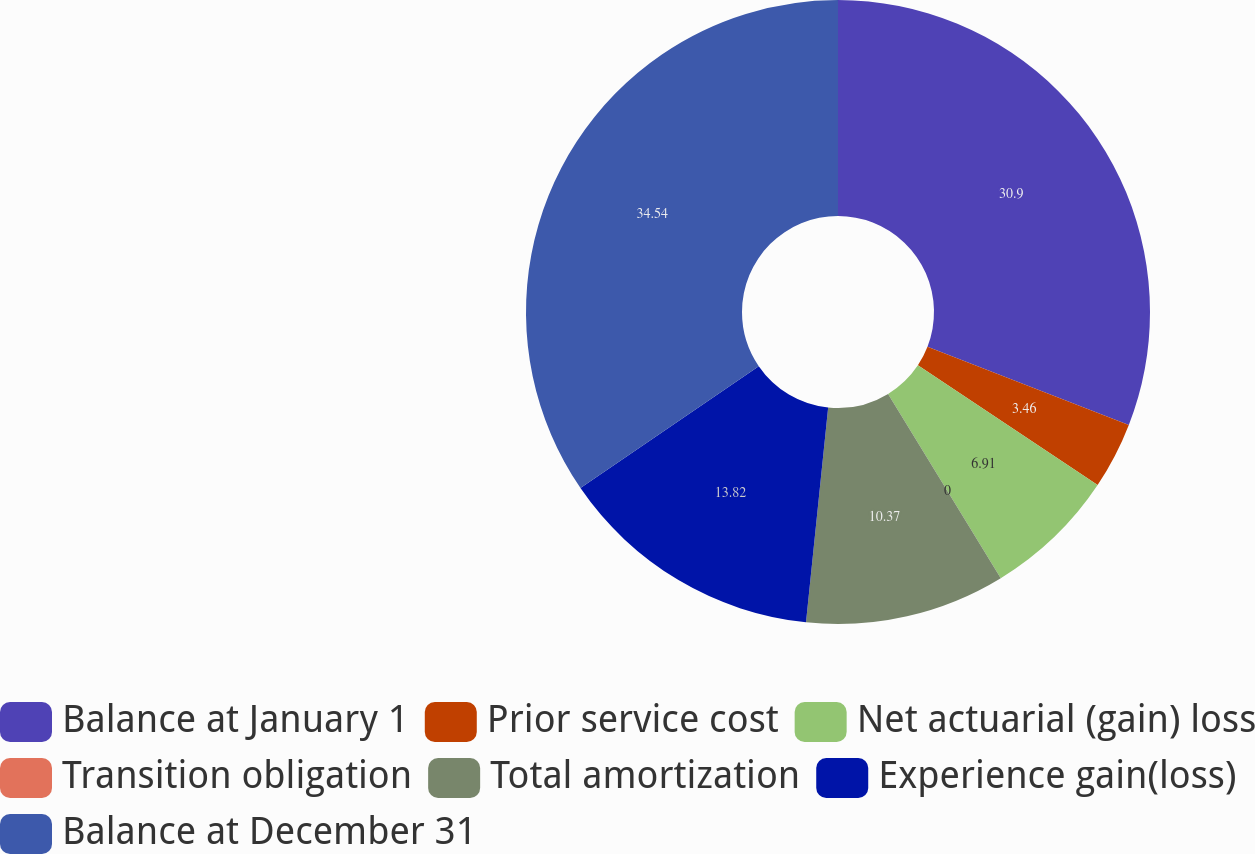<chart> <loc_0><loc_0><loc_500><loc_500><pie_chart><fcel>Balance at January 1<fcel>Prior service cost<fcel>Net actuarial (gain) loss<fcel>Transition obligation<fcel>Total amortization<fcel>Experience gain(loss)<fcel>Balance at December 31<nl><fcel>30.9%<fcel>3.46%<fcel>6.91%<fcel>0.0%<fcel>10.37%<fcel>13.82%<fcel>34.55%<nl></chart> 